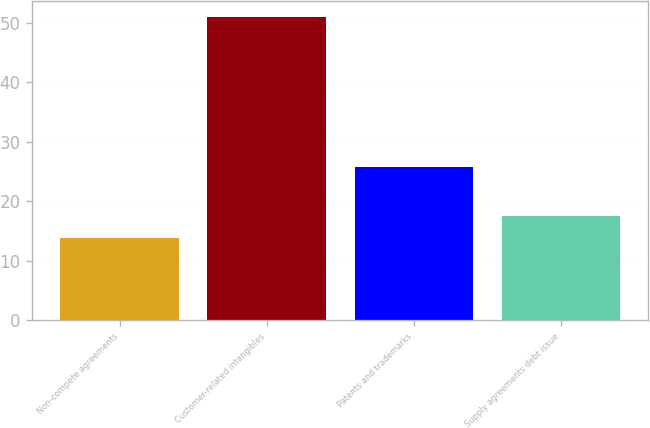Convert chart. <chart><loc_0><loc_0><loc_500><loc_500><bar_chart><fcel>Non-compete agreements<fcel>Customer-related intangibles<fcel>Patents and trademarks<fcel>Supply agreements debt issue<nl><fcel>13.8<fcel>51<fcel>25.8<fcel>17.52<nl></chart> 